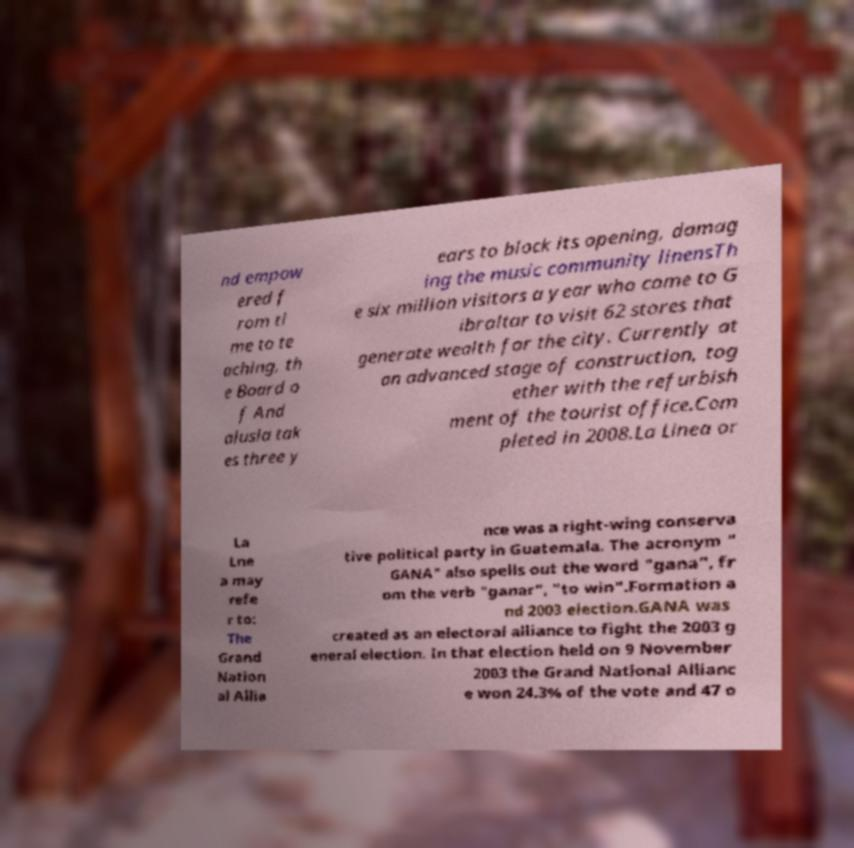Could you assist in decoding the text presented in this image and type it out clearly? nd empow ered f rom ti me to te aching, th e Board o f And alusia tak es three y ears to block its opening, damag ing the music community linensTh e six million visitors a year who come to G ibraltar to visit 62 stores that generate wealth for the city. Currently at an advanced stage of construction, tog ether with the refurbish ment of the tourist office.Com pleted in 2008.La Linea or La Lne a may refe r to: The Grand Nation al Allia nce was a right-wing conserva tive political party in Guatemala. The acronym " GANA" also spells out the word "gana", fr om the verb "ganar", "to win".Formation a nd 2003 election.GANA was created as an electoral alliance to fight the 2003 g eneral election. In that election held on 9 November 2003 the Grand National Allianc e won 24.3% of the vote and 47 o 